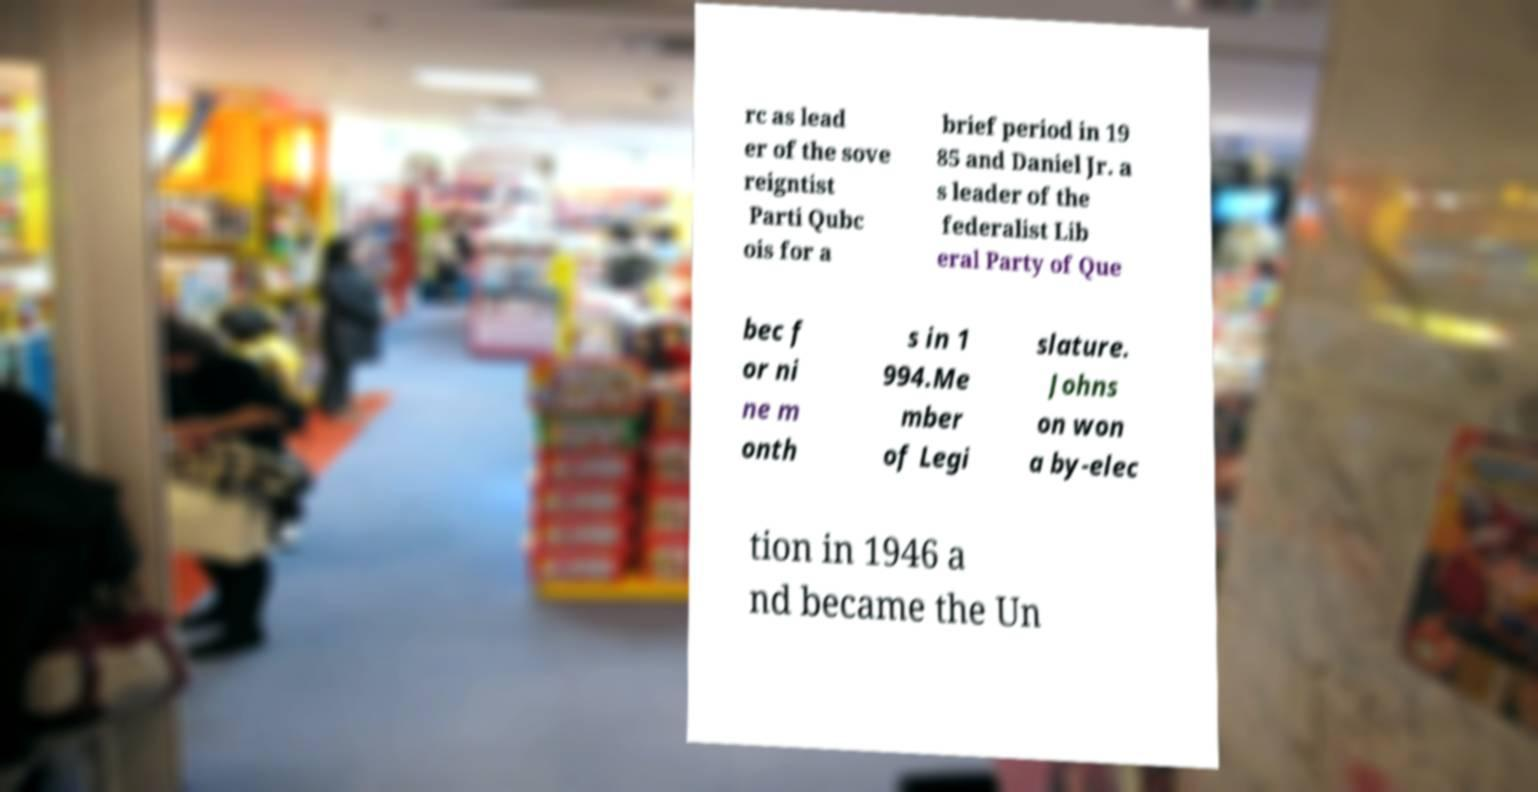What messages or text are displayed in this image? I need them in a readable, typed format. rc as lead er of the sove reigntist Parti Qubc ois for a brief period in 19 85 and Daniel Jr. a s leader of the federalist Lib eral Party of Que bec f or ni ne m onth s in 1 994.Me mber of Legi slature. Johns on won a by-elec tion in 1946 a nd became the Un 